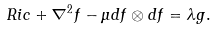Convert formula to latex. <formula><loc_0><loc_0><loc_500><loc_500>R i c + \nabla ^ { 2 } f - \mu d f \otimes d f = \lambda g .</formula> 